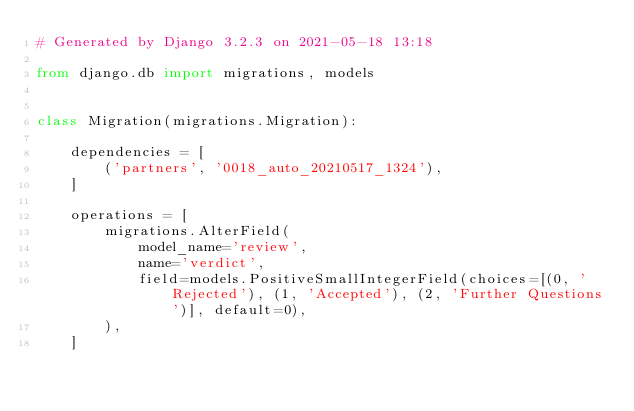<code> <loc_0><loc_0><loc_500><loc_500><_Python_># Generated by Django 3.2.3 on 2021-05-18 13:18

from django.db import migrations, models


class Migration(migrations.Migration):

    dependencies = [
        ('partners', '0018_auto_20210517_1324'),
    ]

    operations = [
        migrations.AlterField(
            model_name='review',
            name='verdict',
            field=models.PositiveSmallIntegerField(choices=[(0, 'Rejected'), (1, 'Accepted'), (2, 'Further Questions')], default=0),
        ),
    ]
</code> 